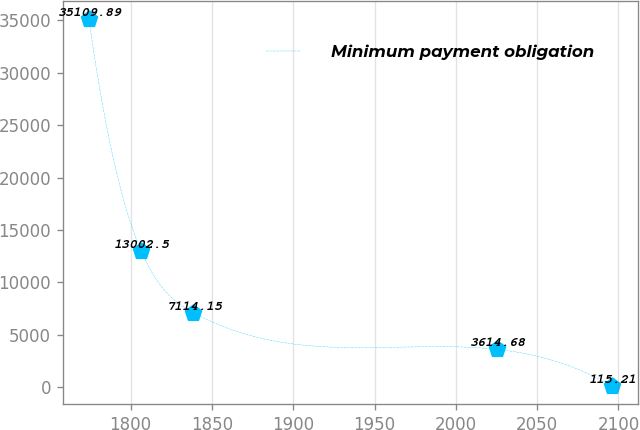Convert chart. <chart><loc_0><loc_0><loc_500><loc_500><line_chart><ecel><fcel>Minimum payment obligation<nl><fcel>1774.31<fcel>35109.9<nl><fcel>1806.48<fcel>13002.5<nl><fcel>1838.65<fcel>7114.15<nl><fcel>2025.23<fcel>3614.68<nl><fcel>2095.99<fcel>115.21<nl></chart> 